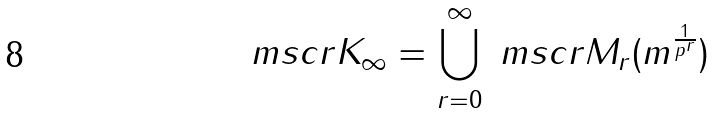Convert formula to latex. <formula><loc_0><loc_0><loc_500><loc_500>\ m s c r K _ { \infty } = \bigcup _ { r = 0 } ^ { \infty } \ m s c r M _ { r } ( m ^ { \frac { 1 } { p ^ { r } } } )</formula> 